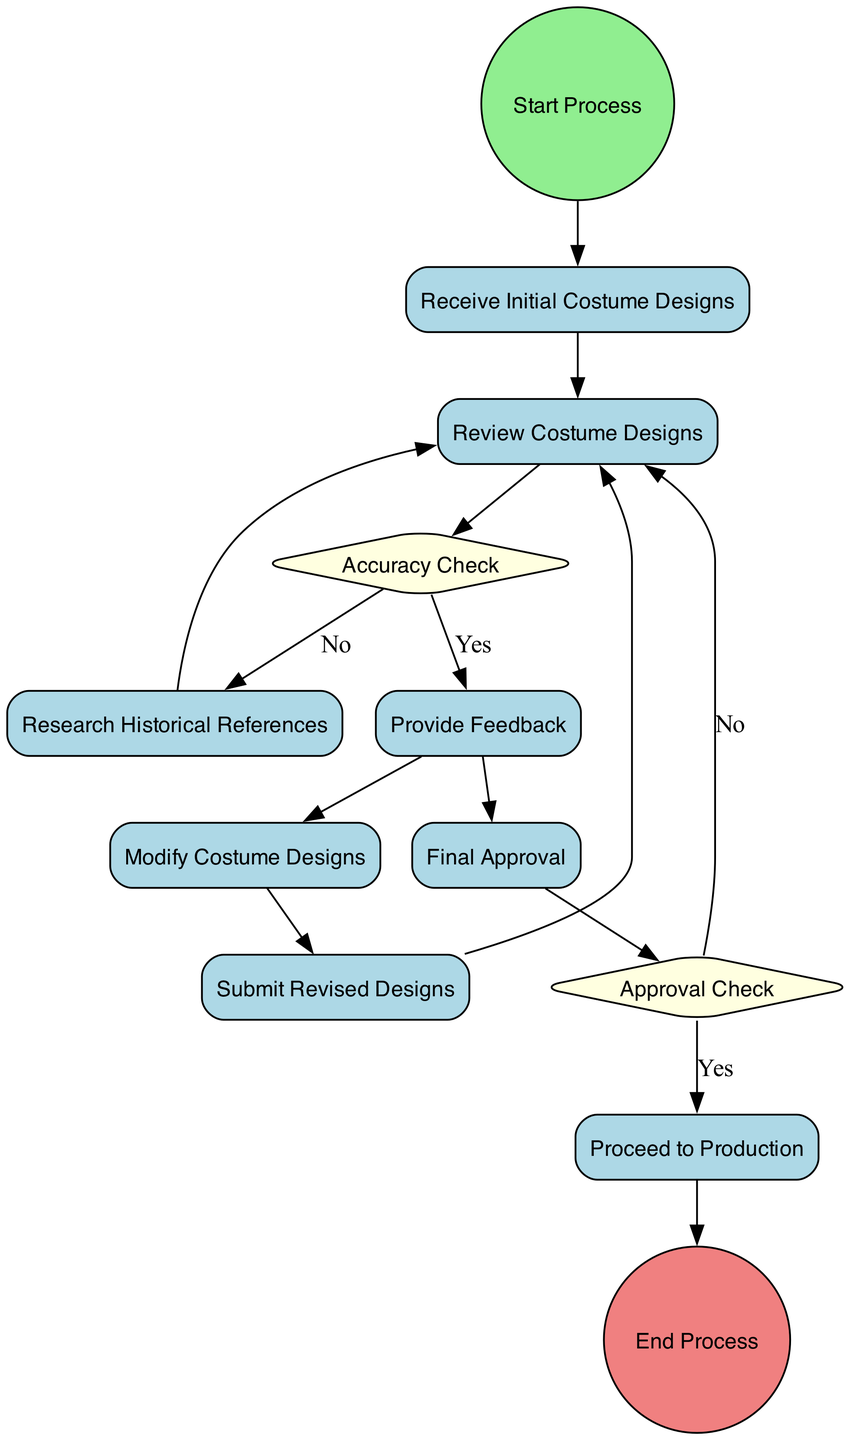What is the first activity in the process? The first activity in the process is represented by the node directly connected to the Start Process node. This node is labeled "Receive Initial Costume Designs."
Answer: Receive Initial Costume Designs How many decision points are there in the diagram? The diagram includes two decision points, "Accuracy Check" and "Approval Check." Both points are represented as diamond-shaped nodes.
Answer: 2 What happens after "Review Costume Designs" if the designs are historically accurate? If the designs are historically accurate, the flow continues from "Review Costume Designs" to the "Provide Feedback" node, indicating the director has accepted the designs.
Answer: Provide Feedback What activity is performed after the final approval of the costume designs? After the final approval, the next activity is "Proceed to Production." This step signifies the movement from design approval to garment creation.
Answer: Proceed to Production What is the consequence if the costume designs do not pass the accuracy check? If the designs do not pass the accuracy check, the process flows to "Research Historical References" before returning to re-evaluate the costume designs.
Answer: Research Historical References Which activity involves consulting historical references? "Research Historical References" is the activity that involves the director and team consulting historical references for validating costume details.
Answer: Research Historical References In the diagram, how does a costume designer know to modify the designs? The costume designer knows to modify the designs based on the feedback provided by the director after the review of the initial designs. This is indicated by the "Provide Feedback" node.
Answer: Modify Costume Designs What is the final step of the process depicted in the diagram? The final step of the process is indicated by the "End Process" node, which concludes the sequence of events.
Answer: End Process 